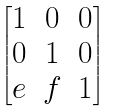<formula> <loc_0><loc_0><loc_500><loc_500>\begin{bmatrix} 1 & 0 & 0 \\ 0 & 1 & 0 \\ e & f & 1 \\ \end{bmatrix}</formula> 